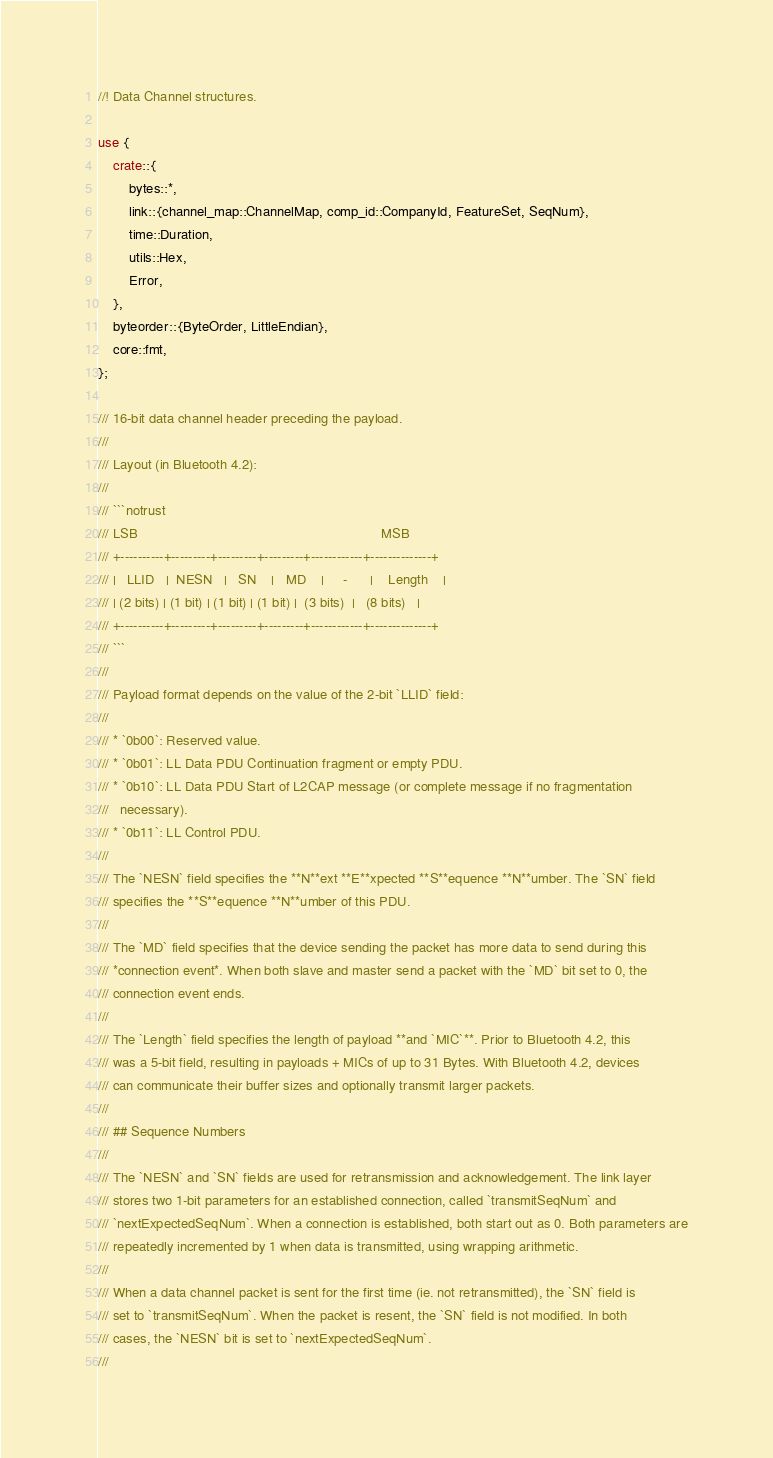Convert code to text. <code><loc_0><loc_0><loc_500><loc_500><_Rust_>//! Data Channel structures.

use {
    crate::{
        bytes::*,
        link::{channel_map::ChannelMap, comp_id::CompanyId, FeatureSet, SeqNum},
        time::Duration,
        utils::Hex,
        Error,
    },
    byteorder::{ByteOrder, LittleEndian},
    core::fmt,
};

/// 16-bit data channel header preceding the payload.
///
/// Layout (in Bluetooth 4.2):
///
/// ```notrust
/// LSB                                                                MSB
/// +----------+---------+---------+---------+------------+--------------+
/// |   LLID   |  NESN   |   SN    |   MD    |     -      |    Length    |
/// | (2 bits) | (1 bit) | (1 bit) | (1 bit) |  (3 bits)  |   (8 bits)   |
/// +----------+---------+---------+---------+------------+--------------+
/// ```
///
/// Payload format depends on the value of the 2-bit `LLID` field:
///
/// * `0b00`: Reserved value.
/// * `0b01`: LL Data PDU Continuation fragment or empty PDU.
/// * `0b10`: LL Data PDU Start of L2CAP message (or complete message if no fragmentation
///   necessary).
/// * `0b11`: LL Control PDU.
///
/// The `NESN` field specifies the **N**ext **E**xpected **S**equence **N**umber. The `SN` field
/// specifies the **S**equence **N**umber of this PDU.
///
/// The `MD` field specifies that the device sending the packet has more data to send during this
/// *connection event*. When both slave and master send a packet with the `MD` bit set to 0, the
/// connection event ends.
///
/// The `Length` field specifies the length of payload **and `MIC`**. Prior to Bluetooth 4.2, this
/// was a 5-bit field, resulting in payloads + MICs of up to 31 Bytes. With Bluetooth 4.2, devices
/// can communicate their buffer sizes and optionally transmit larger packets.
///
/// ## Sequence Numbers
///
/// The `NESN` and `SN` fields are used for retransmission and acknowledgement. The link layer
/// stores two 1-bit parameters for an established connection, called `transmitSeqNum` and
/// `nextExpectedSeqNum`. When a connection is established, both start out as 0. Both parameters are
/// repeatedly incremented by 1 when data is transmitted, using wrapping arithmetic.
///
/// When a data channel packet is sent for the first time (ie. not retransmitted), the `SN` field is
/// set to `transmitSeqNum`. When the packet is resent, the `SN` field is not modified. In both
/// cases, the `NESN` bit is set to `nextExpectedSeqNum`.
///</code> 